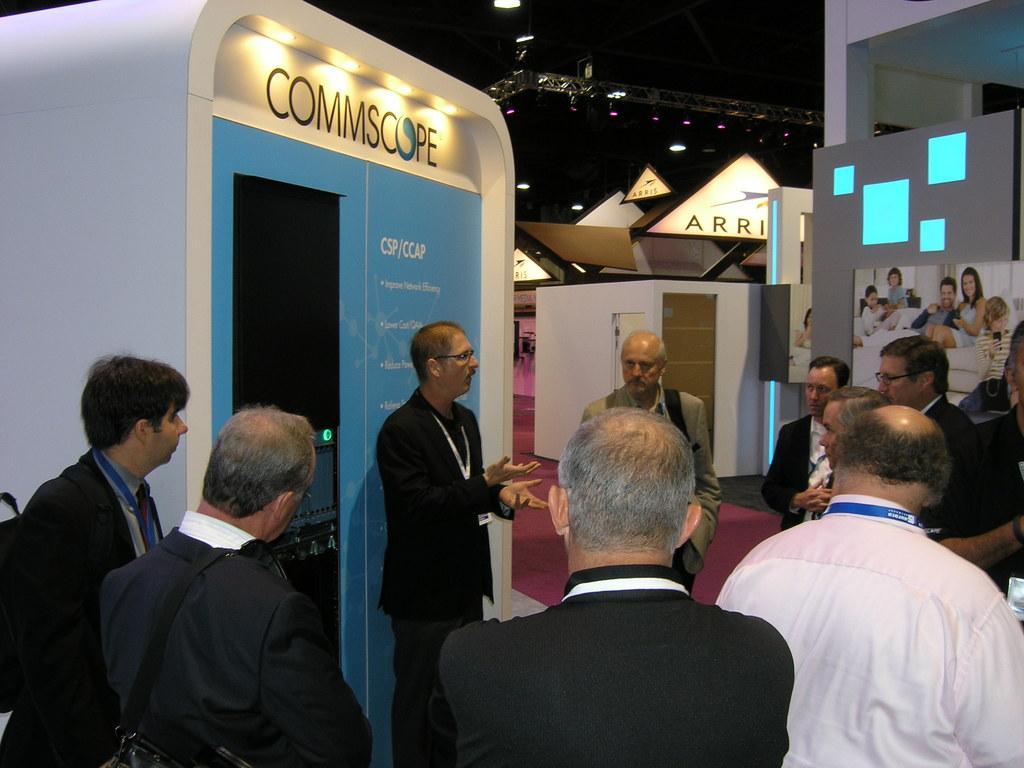How would you summarize this image in a sentence or two? In this picture we can see some people standing in the front, a man in the middle is speaking something, in the background there is a poster, we can see lights at the top of the picture, there is some text here. 